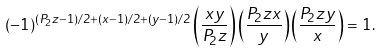<formula> <loc_0><loc_0><loc_500><loc_500>( - 1 ) ^ { ( P _ { 2 } z - 1 ) / 2 + ( x - 1 ) / 2 + ( y - 1 ) / 2 } \left ( \frac { x y } { P _ { 2 } z } \right ) \left ( \frac { P _ { 2 } z x } { y } \right ) \left ( \frac { P _ { 2 } z y } { x } \right ) = 1 .</formula> 